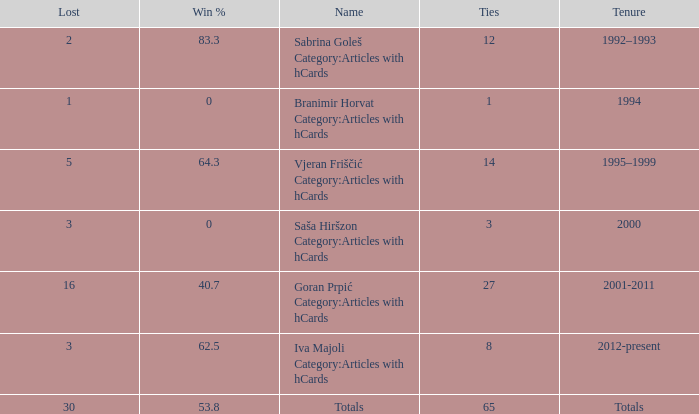Tell me the total number of ties for name of totals and lost more than 30 0.0. 